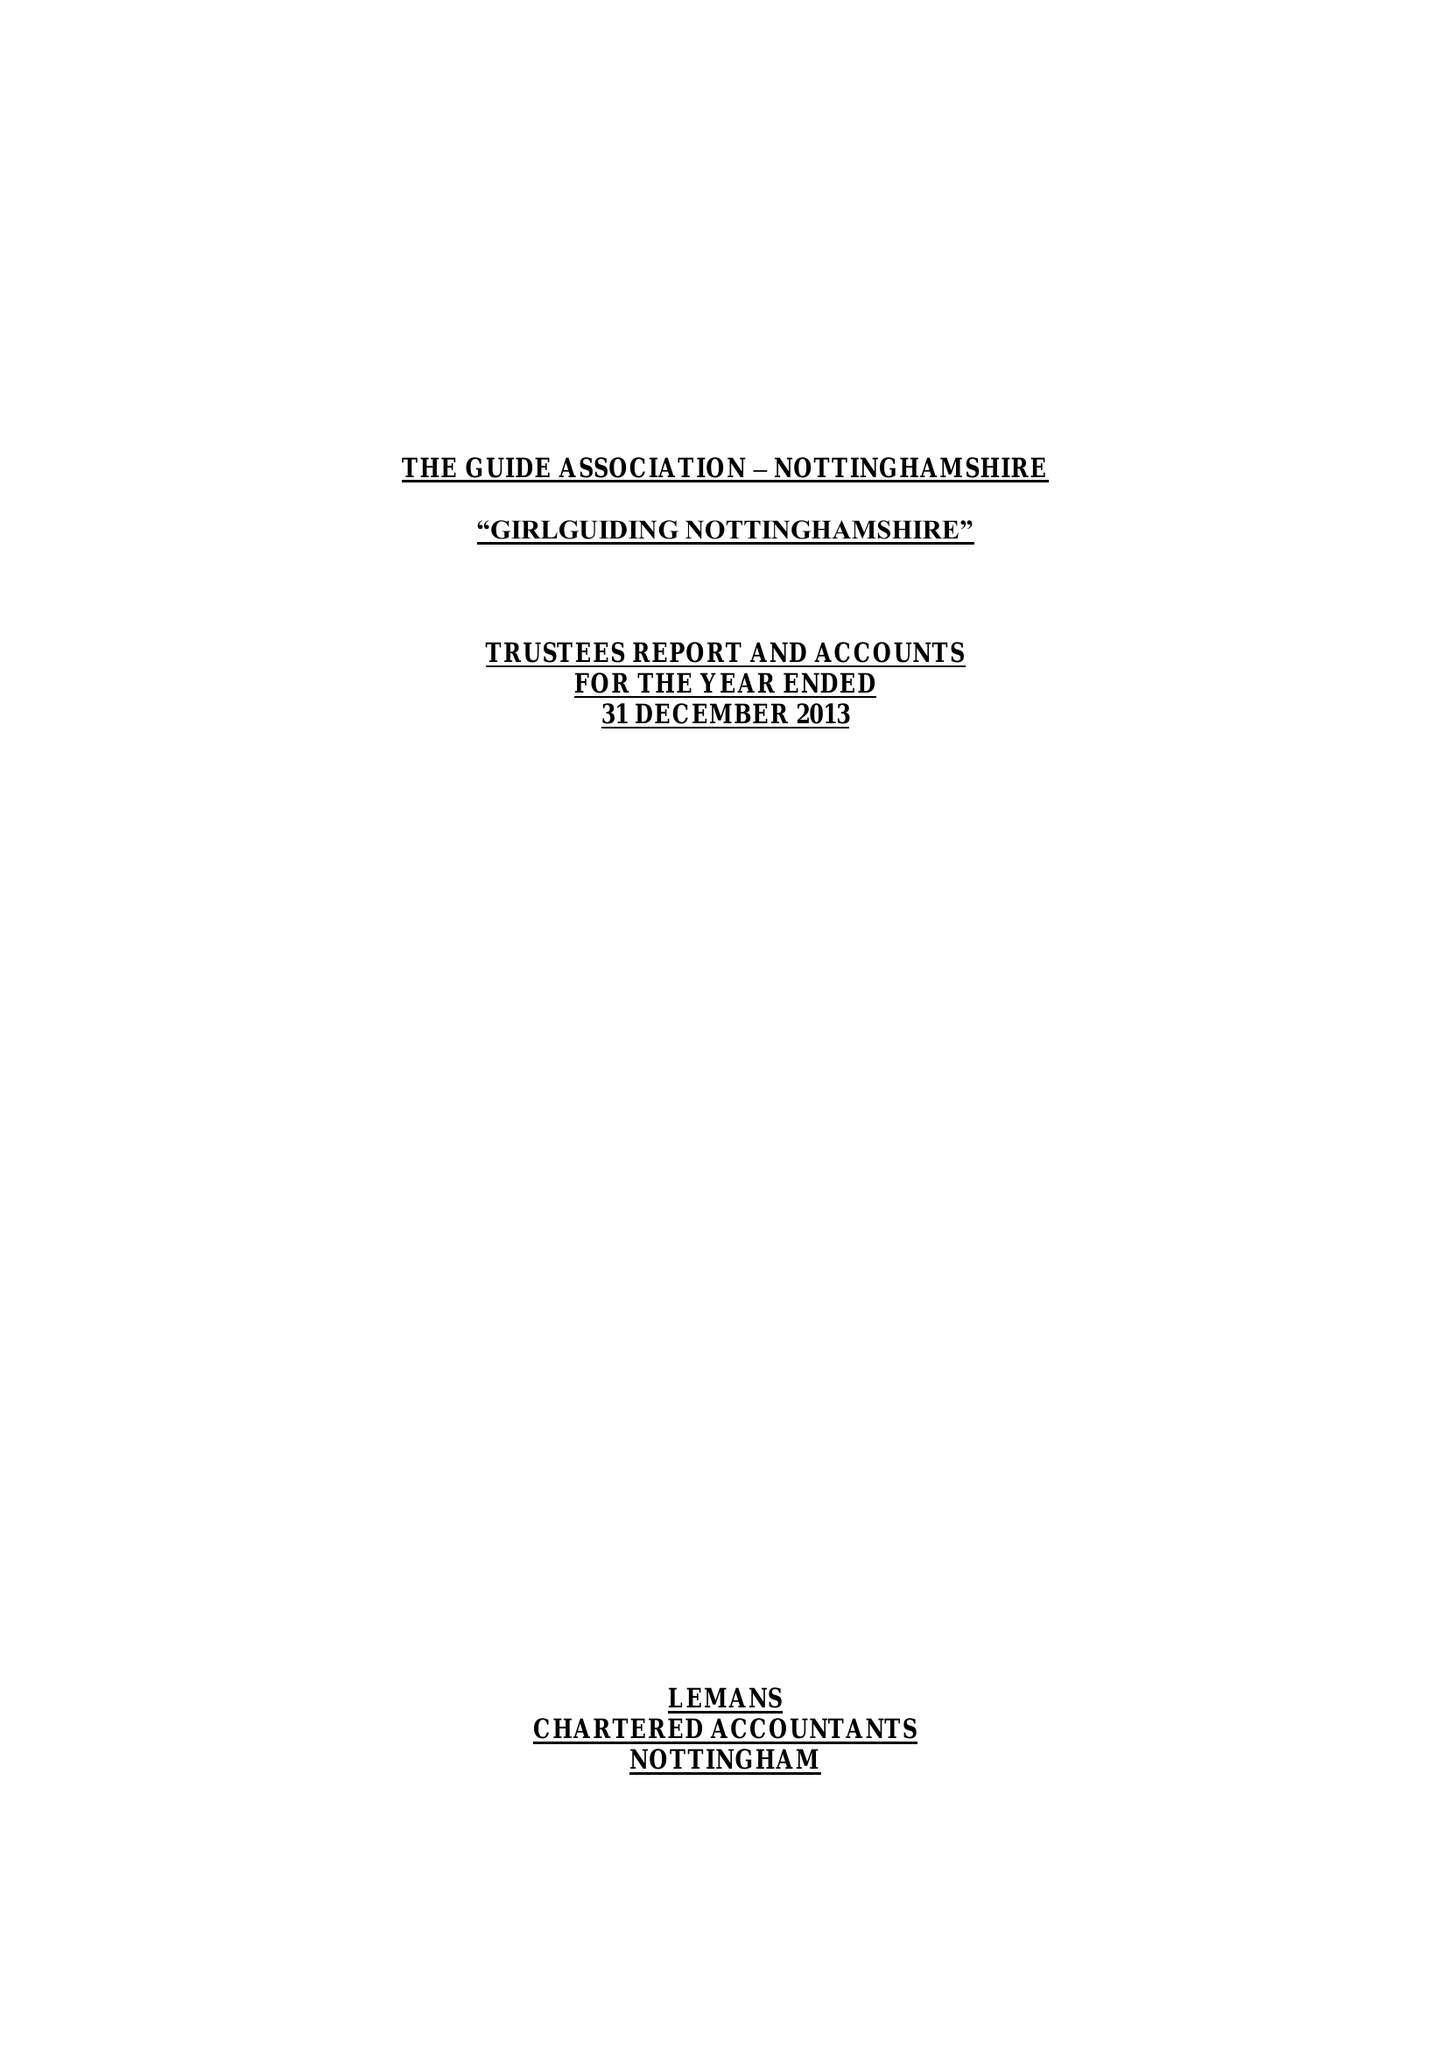What is the value for the charity_number?
Answer the question using a single word or phrase. 503168 